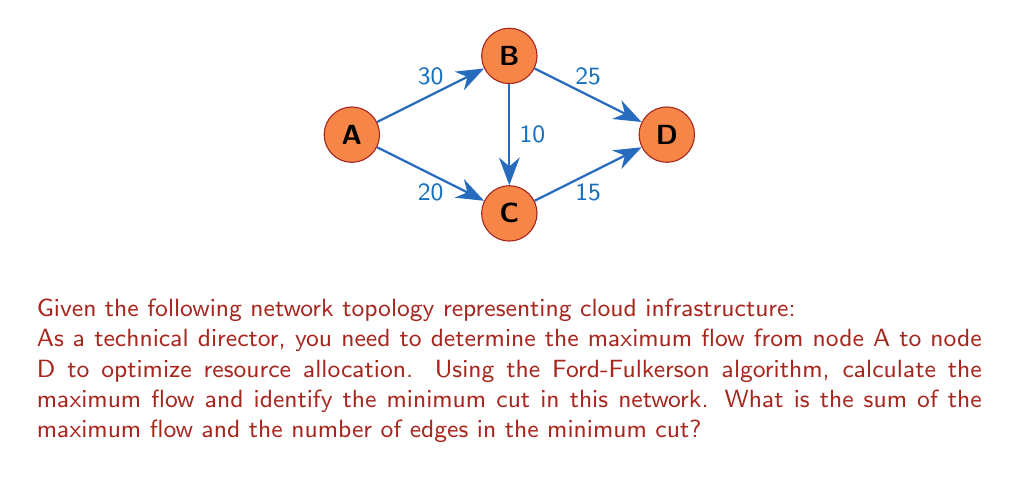Could you help me with this problem? To solve this problem, we'll use the Ford-Fulkerson algorithm to find the maximum flow and identify the minimum cut.

Step 1: Initialize flow to 0 for all edges.

Step 2: Find augmenting paths and update the flow:

1) Path A-B-D: min(30, 25) = 25
   Update: A-B: 25/30, B-D: 25/25
   
2) Path A-C-D: min(20, 15) = 15
   Update: A-C: 15/20, C-D: 15/15
   
3) Path A-B-C-D: min(5, 10, 0) = 0
   No more augmenting paths

Step 3: Calculate maximum flow:
Maximum flow = Flow through B-D + Flow through C-D = 25 + 15 = 40

Step 4: Identify the minimum cut:
- Saturated edges: B-D, C-D
- Minimum cut: {A-B, A-C}

Step 5: Count edges in the minimum cut:
Number of edges in minimum cut = 2

Step 6: Calculate the sum:
Sum = Maximum flow + Number of edges in minimum cut
    = 40 + 2 = 42

Therefore, the maximum flow is 40, and the minimum cut consists of edges A-B and A-C. The sum of the maximum flow and the number of edges in the minimum cut is 42.
Answer: 42 